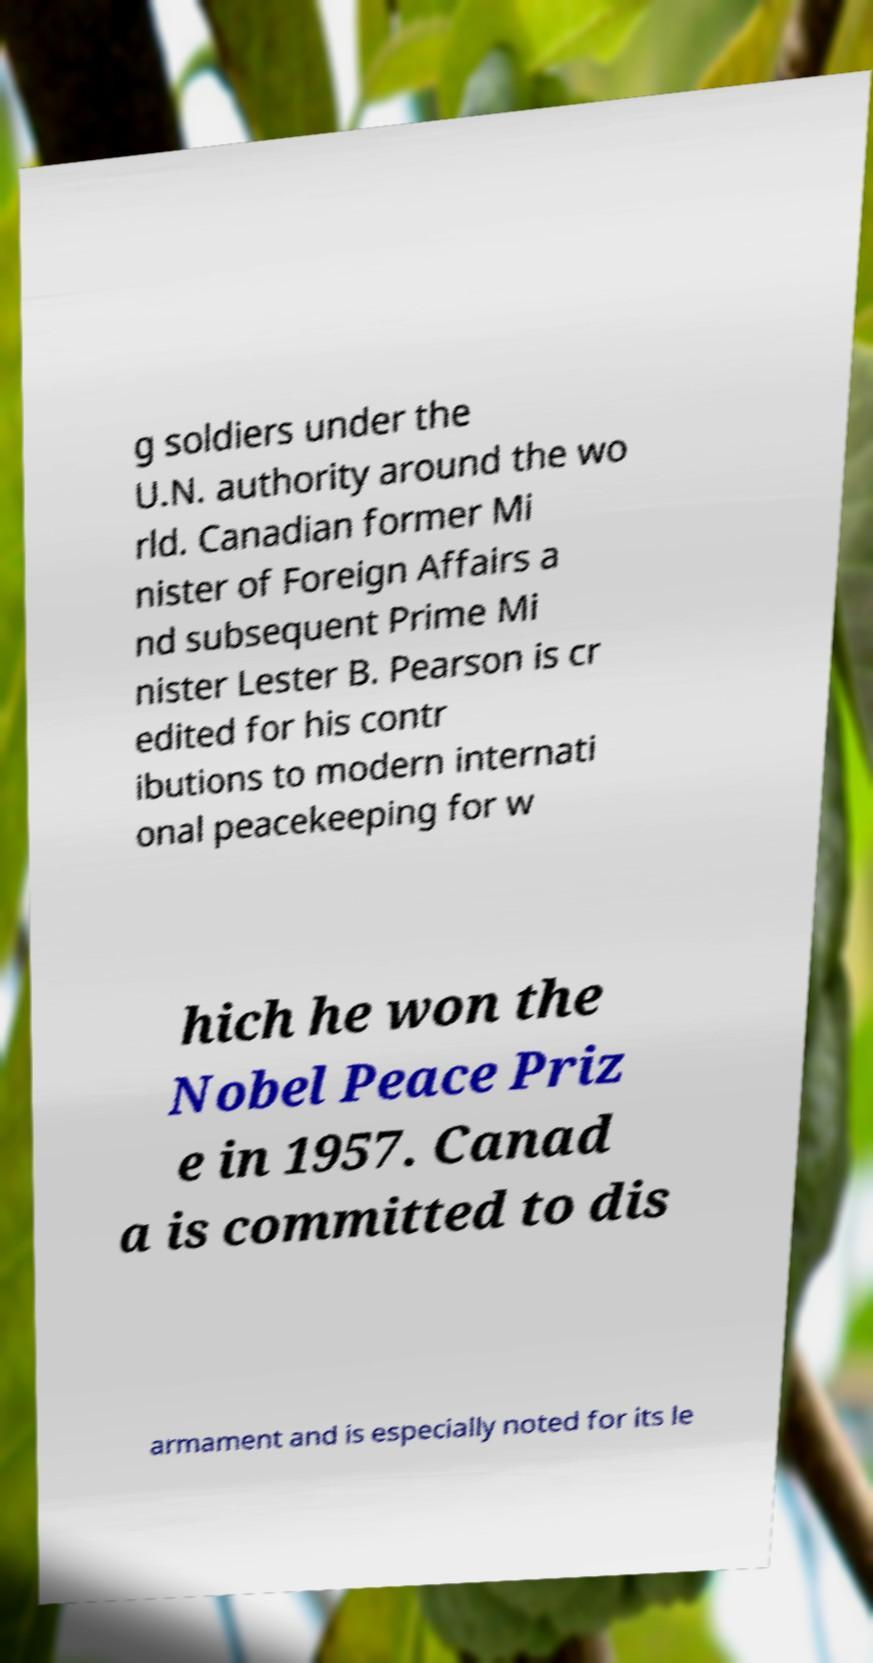Please identify and transcribe the text found in this image. g soldiers under the U.N. authority around the wo rld. Canadian former Mi nister of Foreign Affairs a nd subsequent Prime Mi nister Lester B. Pearson is cr edited for his contr ibutions to modern internati onal peacekeeping for w hich he won the Nobel Peace Priz e in 1957. Canad a is committed to dis armament and is especially noted for its le 